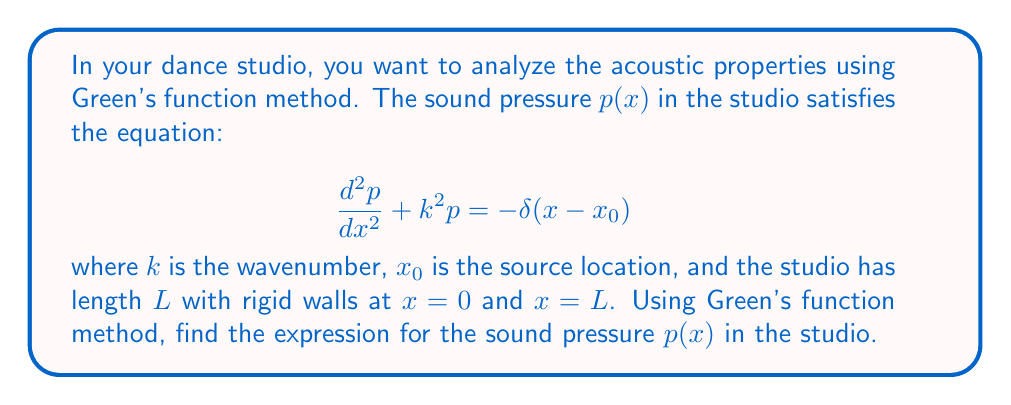Help me with this question. 1) First, we need to find the Green's function $G(x,x_0)$ that satisfies:

   $$\frac{d^2G}{dx^2} + k^2G = -\delta(x-x_0)$$

   with boundary conditions $G'(0,x_0) = G'(L,x_0) = 0$ (rigid walls).

2) The general solution for $G(x,x_0)$ is:

   $$G(x,x_0) = A\cos(kx) + B\sin(kx) + \frac{1}{k}\sin(k|x-x_0|)$$

3) Apply the boundary conditions:
   
   At $x=0$: $G'(0,x_0) = 0 \implies B = 0$
   
   At $x=L$: $G'(L,x_0) = 0 \implies -Ak\sin(kL) + \cos(k(L-x_0)) = 0$

   Therefore, $A = \frac{\cos(k(L-x_0))}{k\sin(kL)}$

4) The Green's function is:

   $$G(x,x_0) = \frac{\cos(k(L-x_0))}{k\sin(kL)}\cos(kx) + \frac{1}{k}\sin(k|x-x_0|)$$

5) The solution $p(x)$ is given by:

   $$p(x) = \int_0^L G(x,x_0)(-\delta(x-x_0))dx_0 = G(x,x_0)$$

6) Therefore, the final expression for the sound pressure is:

   $$p(x) = \frac{\cos(k(L-x_0))}{k\sin(kL)}\cos(kx) + \frac{1}{k}\sin(k|x-x_0|)$$
Answer: $$p(x) = \frac{\cos(k(L-x_0))}{k\sin(kL)}\cos(kx) + \frac{1}{k}\sin(k|x-x_0|)$$ 